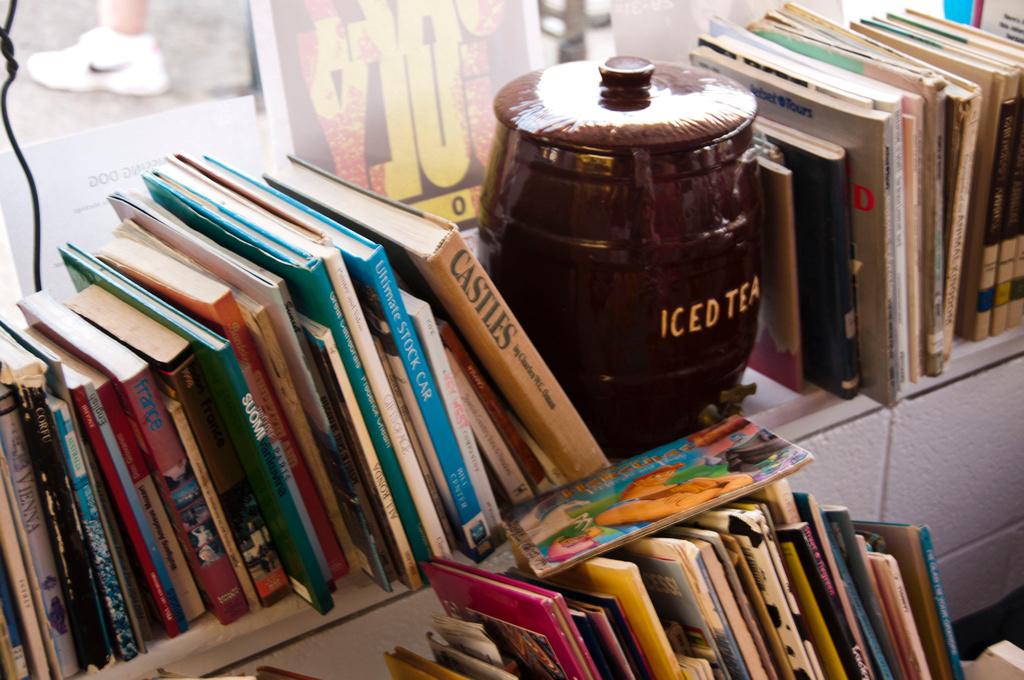 what drink is mentioned on the brown cup?
Provide a short and direct response. Iced tea. What is the book to the left of the brown cup called?
Give a very brief answer. Castles. 